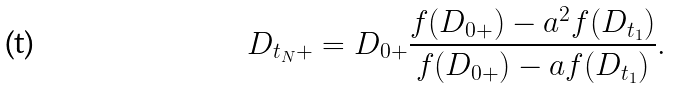<formula> <loc_0><loc_0><loc_500><loc_500>D _ { t _ { N } + } = D _ { 0 + } \frac { f ( D _ { 0 + } ) - { a } ^ { 2 } f ( D _ { t _ { 1 } } ) } { f ( D _ { 0 + } ) - { a } f ( D _ { t _ { 1 } } ) } .</formula> 